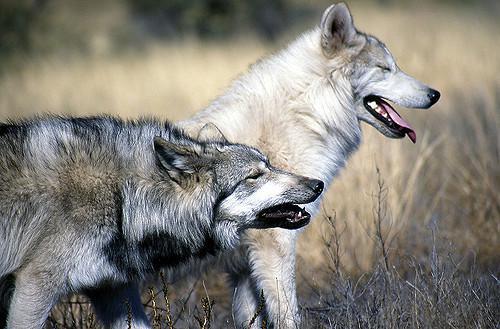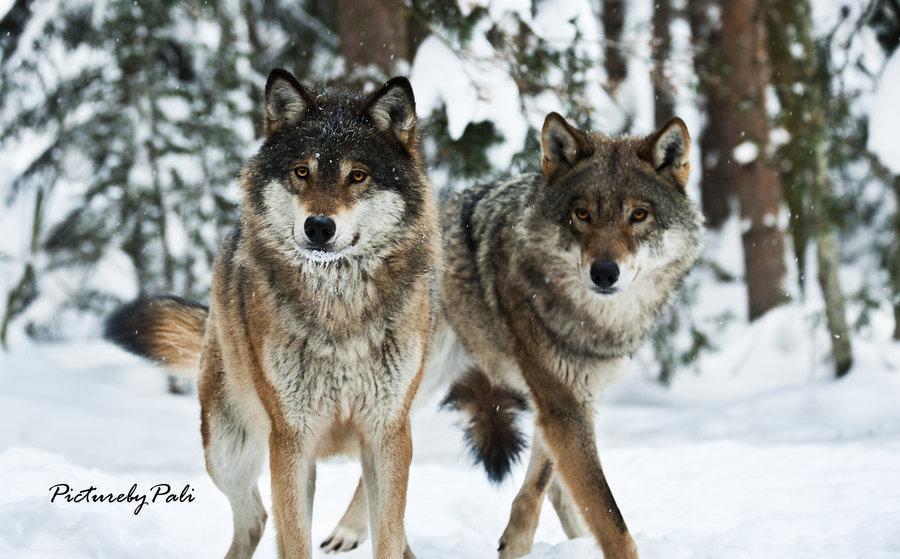The first image is the image on the left, the second image is the image on the right. Examine the images to the left and right. Is the description "An image shows two non-standing wolves with heads nuzzling close together." accurate? Answer yes or no. No. The first image is the image on the left, the second image is the image on the right. Evaluate the accuracy of this statement regarding the images: "a pair of wolves are cuddling with faces close". Is it true? Answer yes or no. No. 